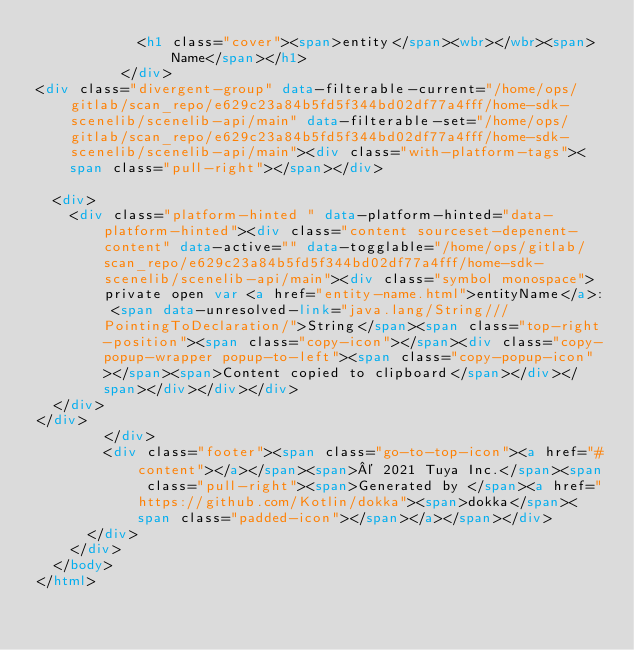<code> <loc_0><loc_0><loc_500><loc_500><_HTML_>            <h1 class="cover"><span>entity</span><wbr></wbr><span>Name</span></h1>
          </div>
<div class="divergent-group" data-filterable-current="/home/ops/gitlab/scan_repo/e629c23a84b5fd5f344bd02df77a4fff/home-sdk-scenelib/scenelib-api/main" data-filterable-set="/home/ops/gitlab/scan_repo/e629c23a84b5fd5f344bd02df77a4fff/home-sdk-scenelib/scenelib-api/main"><div class="with-platform-tags"><span class="pull-right"></span></div>

  <div>
    <div class="platform-hinted " data-platform-hinted="data-platform-hinted"><div class="content sourceset-depenent-content" data-active="" data-togglable="/home/ops/gitlab/scan_repo/e629c23a84b5fd5f344bd02df77a4fff/home-sdk-scenelib/scenelib-api/main"><div class="symbol monospace">private open var <a href="entity-name.html">entityName</a>: <span data-unresolved-link="java.lang/String///PointingToDeclaration/">String</span><span class="top-right-position"><span class="copy-icon"></span><div class="copy-popup-wrapper popup-to-left"><span class="copy-popup-icon"></span><span>Content copied to clipboard</span></div></span></div></div></div>
  </div>
</div>
        </div>
        <div class="footer"><span class="go-to-top-icon"><a href="#content"></a></span><span>© 2021 Tuya Inc.</span><span class="pull-right"><span>Generated by </span><a href="https://github.com/Kotlin/dokka"><span>dokka</span><span class="padded-icon"></span></a></span></div>
      </div>
    </div>
  </body>
</html>

</code> 